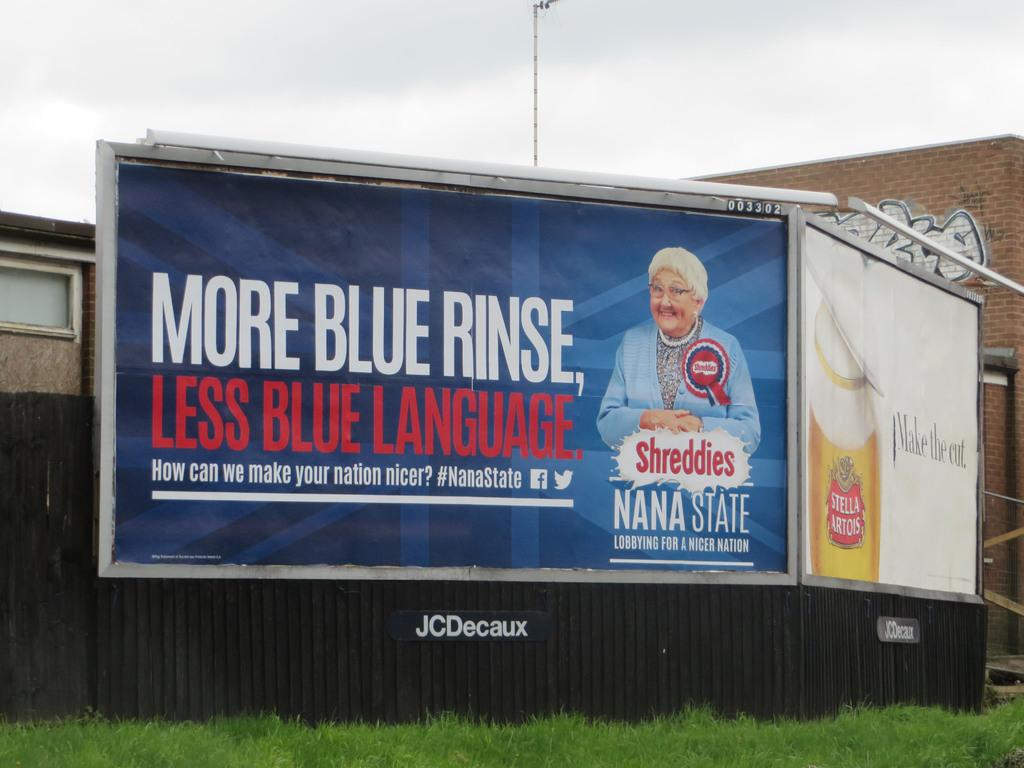<image>
Render a clear and concise summary of the photo. A billboard says More Blue Rinse, Less Blue Language. 